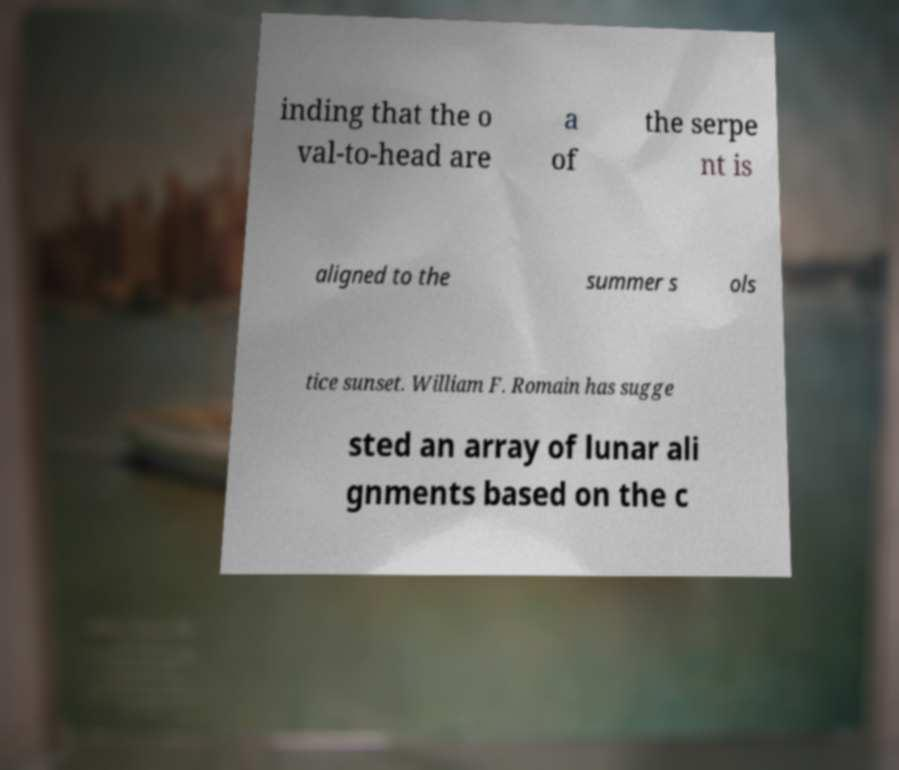I need the written content from this picture converted into text. Can you do that? inding that the o val-to-head are a of the serpe nt is aligned to the summer s ols tice sunset. William F. Romain has sugge sted an array of lunar ali gnments based on the c 